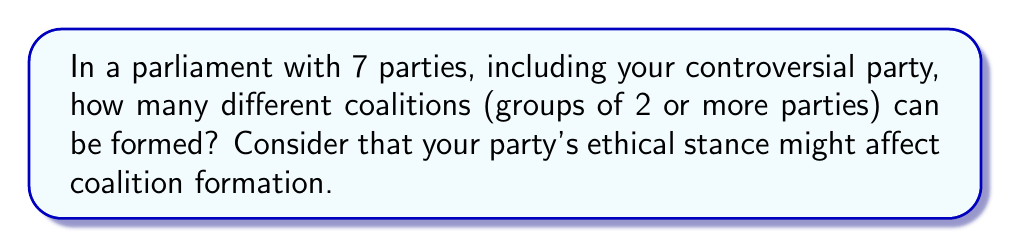Can you answer this question? Let's approach this step-by-step:

1) First, we need to understand that a coalition can be any group of 2 or more parties. This means we need to count all possible combinations of 2, 3, 4, 5, 6, and 7 parties.

2) The number of ways to choose $k$ parties from $n$ parties is given by the combination formula:

   $${n \choose k} = \frac{n!}{k!(n-k)!}$$

3) We need to sum these combinations for $k = 2$ to $k = 7$:

   $$\sum_{k=2}^7 {7 \choose k}$$

4) Let's calculate each term:

   ${7 \choose 2} = \frac{7!}{2!(7-2)!} = 21$
   ${7 \choose 3} = \frac{7!}{3!(7-3)!} = 35$
   ${7 \choose 4} = \frac{7!}{4!(7-4)!} = 35$
   ${7 \choose 5} = \frac{7!}{5!(7-5)!} = 21$
   ${7 \choose 6} = \frac{7!}{6!(7-6)!} = 7$
   ${7 \choose 7} = \frac{7!}{7!(7-7)!} = 1$

5) Sum all these values:

   $21 + 35 + 35 + 21 + 7 + 1 = 120$

Therefore, there are 120 possible coalitions.

Note: This calculation assumes all coalitions are possible. In reality, your party's controversial ethical stance might make some coalitions politically unfeasible, potentially reducing the actual number of viable coalitions.
Answer: 120 